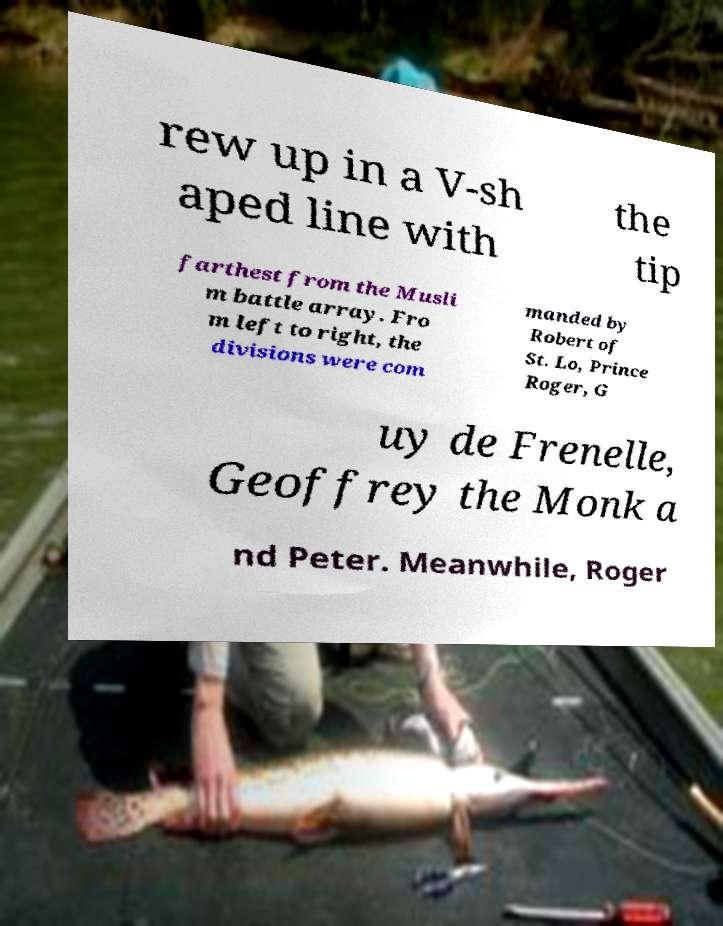Can you accurately transcribe the text from the provided image for me? rew up in a V-sh aped line with the tip farthest from the Musli m battle array. Fro m left to right, the divisions were com manded by Robert of St. Lo, Prince Roger, G uy de Frenelle, Geoffrey the Monk a nd Peter. Meanwhile, Roger 